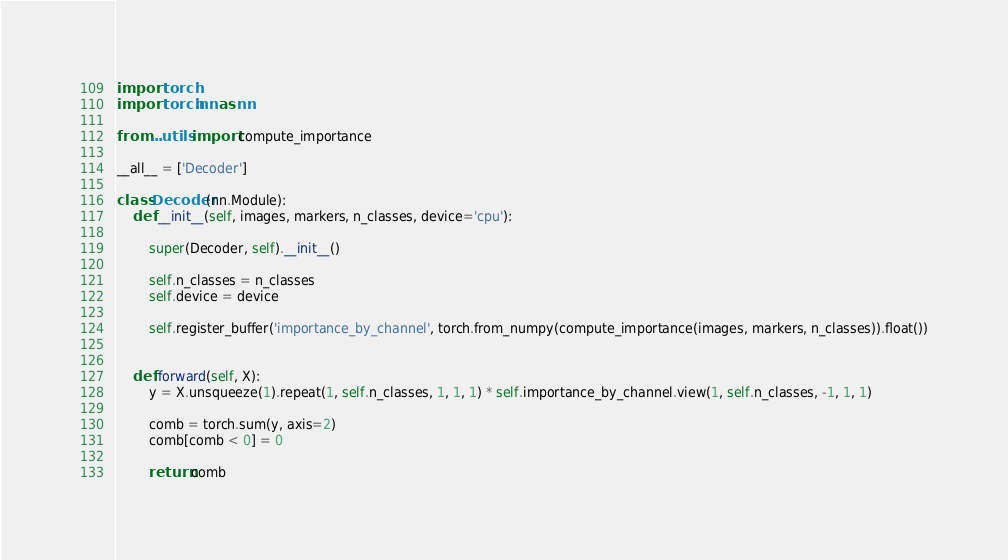<code> <loc_0><loc_0><loc_500><loc_500><_Python_>import torch
import torch.nn as nn

from ...utils import compute_importance

__all__ = ['Decoder']

class Decoder(nn.Module):
    def __init__(self, images, markers, n_classes, device='cpu'):

        super(Decoder, self).__init__()

        self.n_classes = n_classes
        self.device = device

        self.register_buffer('importance_by_channel', torch.from_numpy(compute_importance(images, markers, n_classes)).float())

    
    def forward(self, X):
        y = X.unsqueeze(1).repeat(1, self.n_classes, 1, 1, 1) * self.importance_by_channel.view(1, self.n_classes, -1, 1, 1)

        comb = torch.sum(y, axis=2)
        comb[comb < 0] = 0

        return comb</code> 